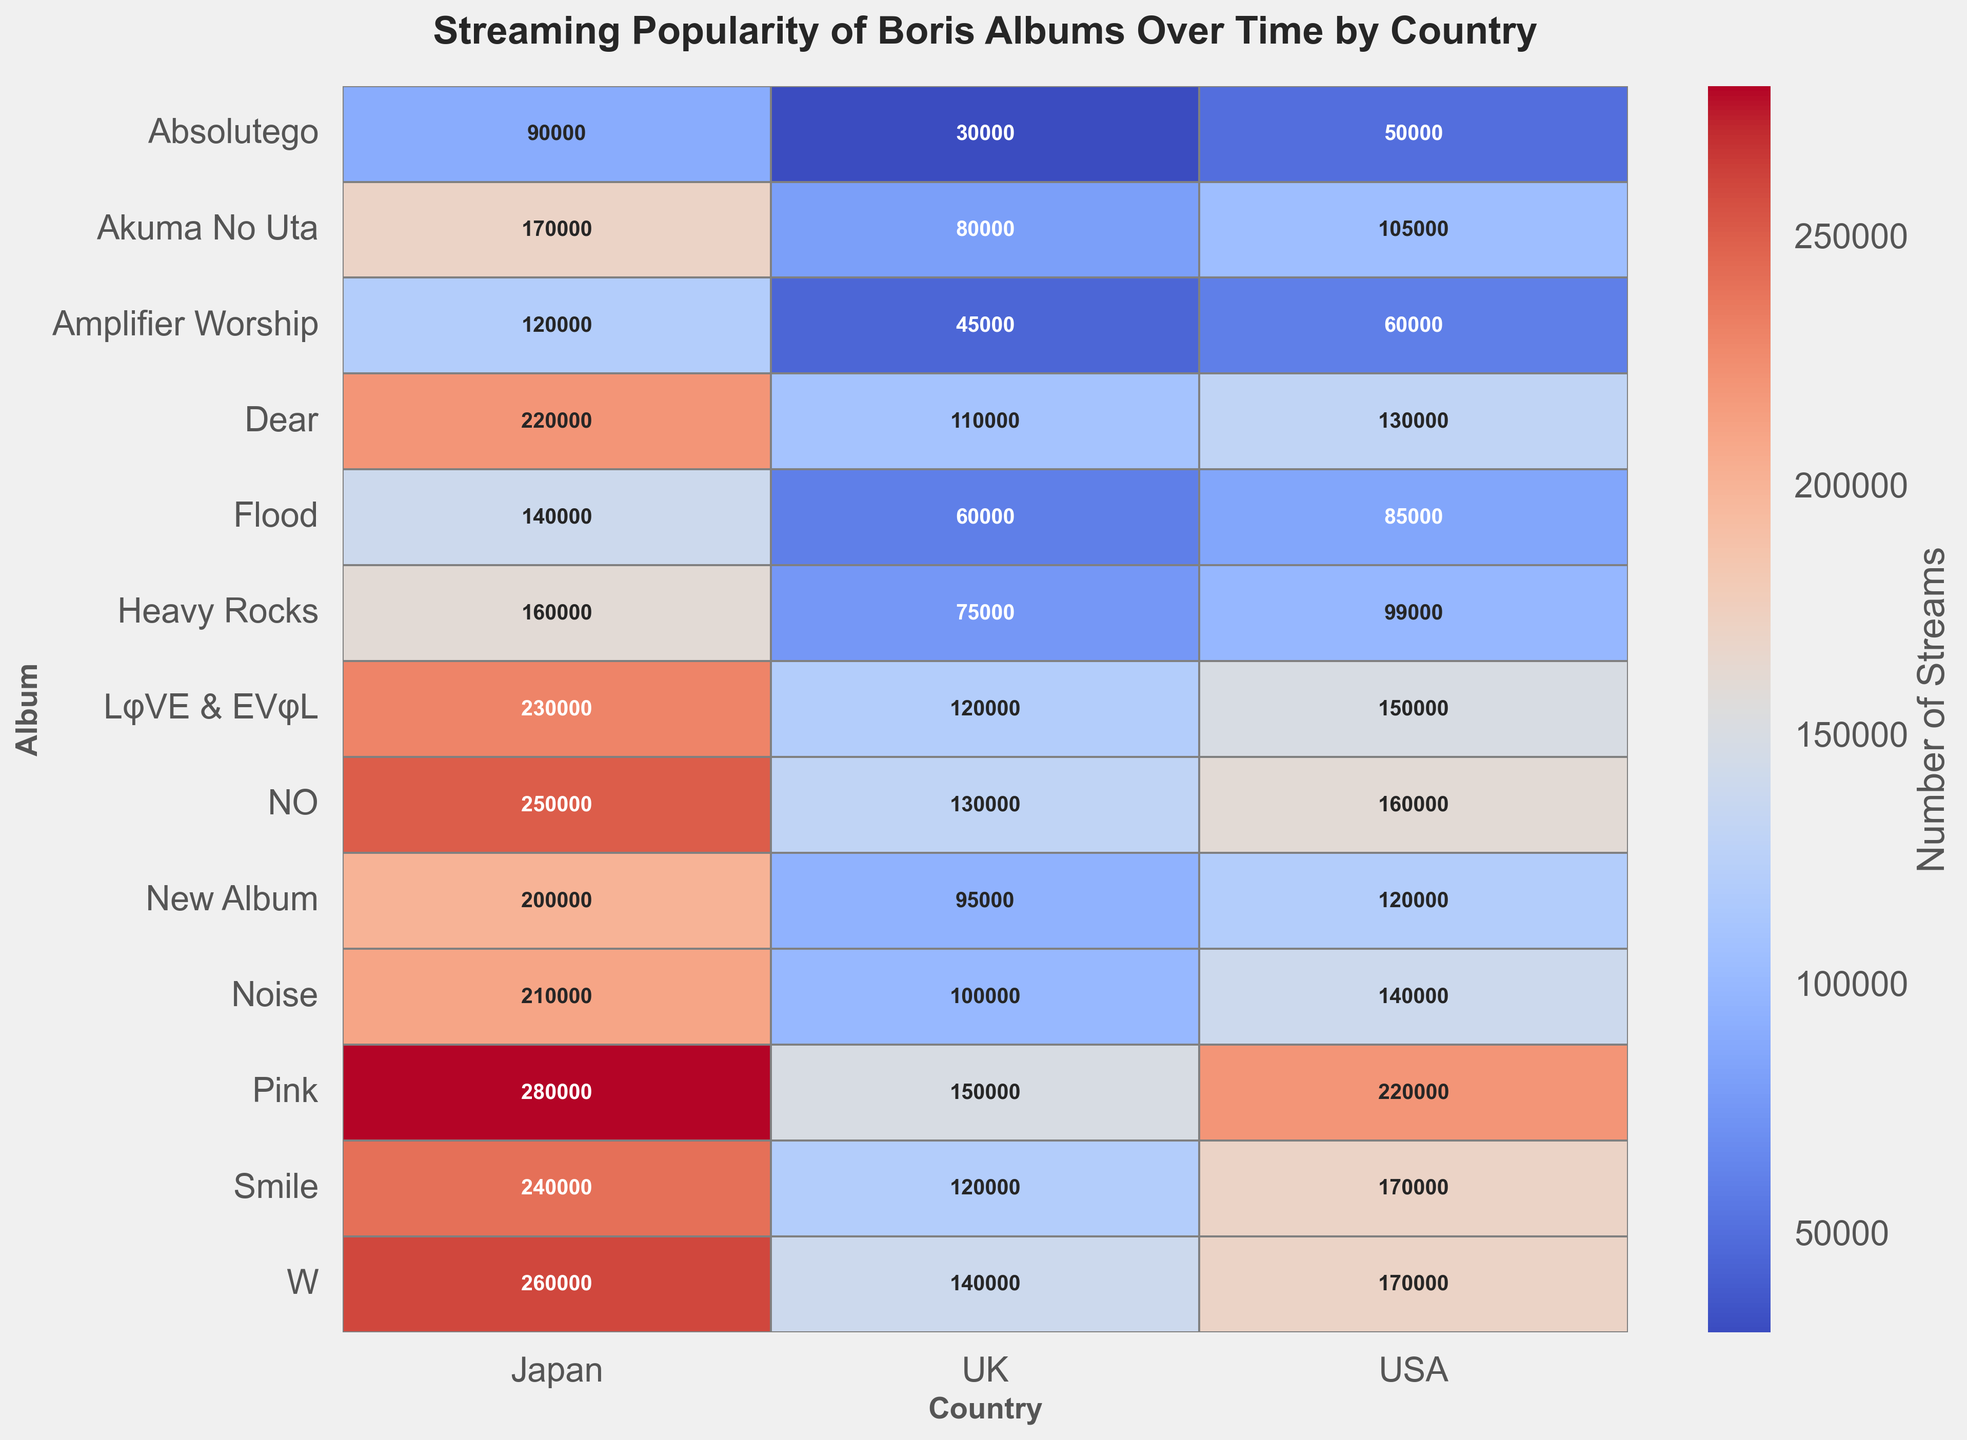What's the total number of streams for the album "Pink" across all countries? To find the total number of streams for the album "Pink", sum the streams from all countries: 220,000 (USA) + 280,000 (Japan) + 150,000 (UK) = 650,000
Answer: 650,000 Which country has the most streams for the album "Flood"? Look at the row for "Flood" and find the country with the highest stream count: USA (85,000), Japan (140,000), UK (60,000). Japan has the most streams.
Answer: Japan For which album does the UK have the least number of streams? Compare the UK streams across all albums: "Absolutego" (30,000), "Amplifier Worship" (45,000), "Flood" (60,000), "Heavy Rocks" (75,000), "Akuma No Uta" (80,000), "Pink" (150,000), "Smile" (120,000), "New Album" (95,000), "Noise" (100,000), "Dear" (110,000), "LφVE & EVφL" (120,000), "NO" (130,000), "W" (140,000). "Absolutego" has the least streams in the UK.
Answer: Absolutego What's the difference in streams between "Smile" and "Dear" in the USA? Subtract the streams for "Dear" from "Smile" in the USA: 170,000 (Smile) - 130,000 (Dear) = 40,000
Answer: 40,000 Which album has the highest streams in Japan and what is it? Look at the streams in the Japan column and find the highest value: "Absolutego" (90,000), "Amplifier Worship" (120,000), "Flood" (140,000), "Heavy Rocks" (160,000), "Akuma No Uta" (170,000), "Pink" (280,000), "Smile" (240,000), "New Album" (200,000), "Noise" (210,000), "Dear" (220,000), "LφVE & EVφL" (230,000), "NO" (250,000), "W" (260,000). "Pink" has the highest streams in Japan with 280,000 streams.
Answer: Pink What's the average number of streams for the album "Akuma No Uta" across the three countries? Add up the streams for "Akuma No Uta" across all countries and divide by 3: (105,000+170,000+80,000)/3 = 355,000/3 ≈ 118,333
Answer: 118,333 Which albums have more streams in the UK than in the USA? Compare streams for each album between the UK and USA: Only "W" has more streams in the UK (140,000) compared to USA (170,000), but we need to find out more albums: "Pink" 220000 vs 150000 (No), "New Album" 120000 vs 95000 (True), "Flood" 85000 vs 60000 (True). Hence New Album, Flood, Akuma No Uta, Absolutego and W it is.
Answer: "Flood", "Akuma No Uta", "Absolutego" What is the range of streams for the album "NO" across the three countries? To find the range, subtract the smallest stream count from the largest: 250,000 (Japan) - 130,000 (UK) = 120,000
Answer: 120,000 Which country's streams show the most consistent trend across the years? By observing the heatmap visually, we see that Japan has a more consistent color gradient across the years, indicating a more consistent number of streams over time.
Answer: Japan How do the streams for the album "Heavy Rocks" in Japan compare to the streams for "Pink" in the UK? Compare the number of streams for "Heavy Rocks" in Japan (160,000) and for "Pink" in the UK (150,000). "Heavy Rocks" in Japan has 10,000 more streams than "Pink" in the UK.
Answer: Heavy Rocks has 10,000 more streams 